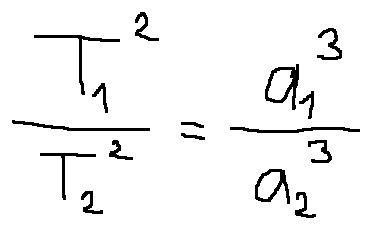<formula> <loc_0><loc_0><loc_500><loc_500>\frac { T _ { 1 } ^ { 2 } } { T _ { 2 } ^ { 2 } } = \frac { a _ { 1 } ^ { 3 } } { a _ { 2 } ^ { 3 } }</formula> 